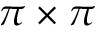<formula> <loc_0><loc_0><loc_500><loc_500>\pi \times \pi</formula> 